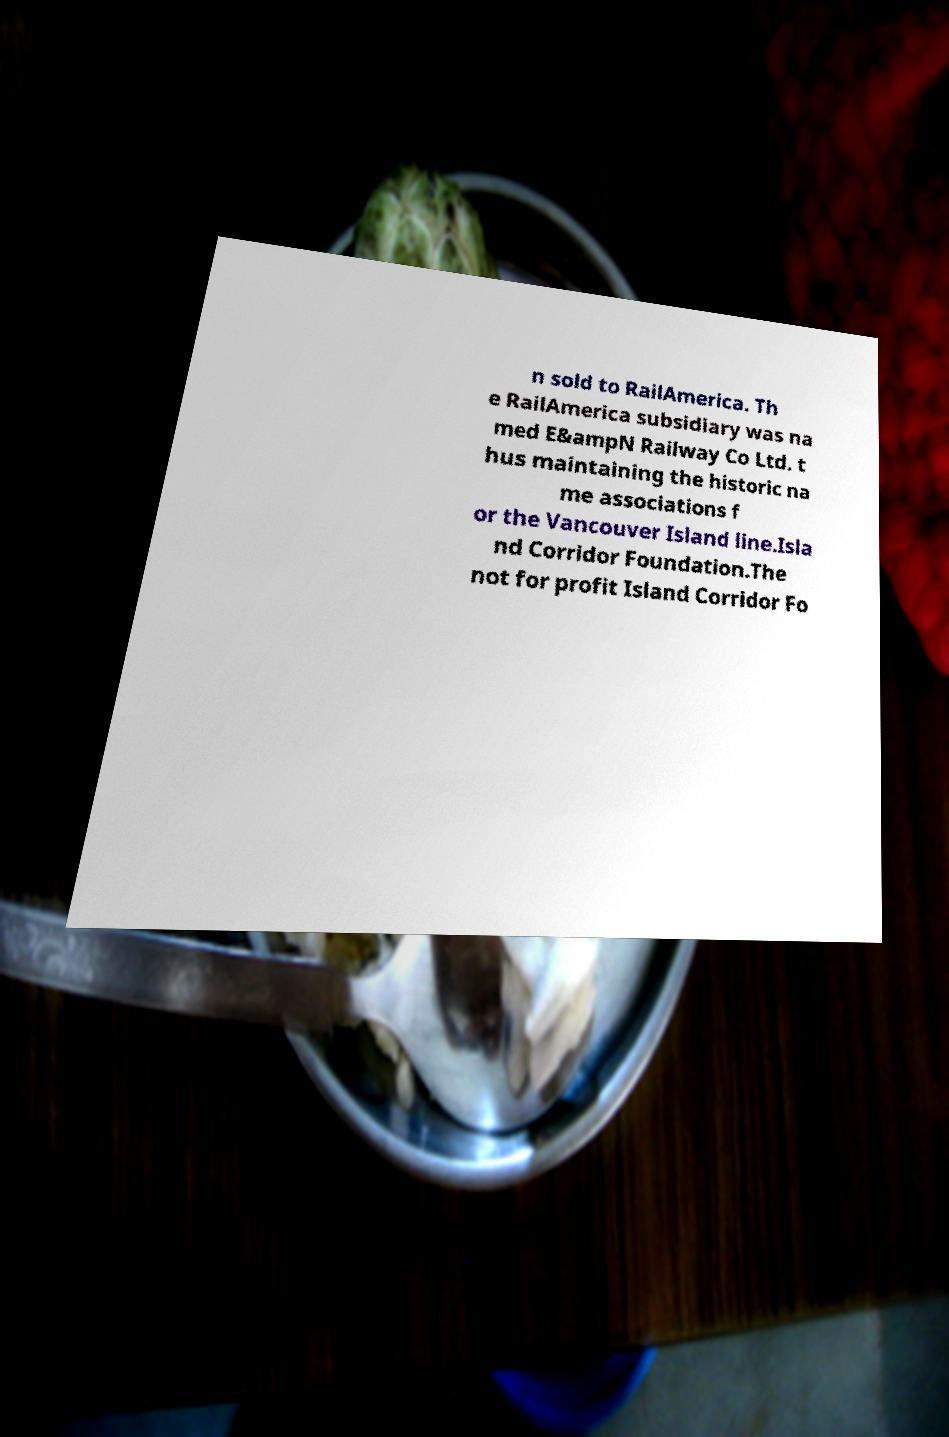I need the written content from this picture converted into text. Can you do that? n sold to RailAmerica. Th e RailAmerica subsidiary was na med E&ampN Railway Co Ltd. t hus maintaining the historic na me associations f or the Vancouver Island line.Isla nd Corridor Foundation.The not for profit Island Corridor Fo 